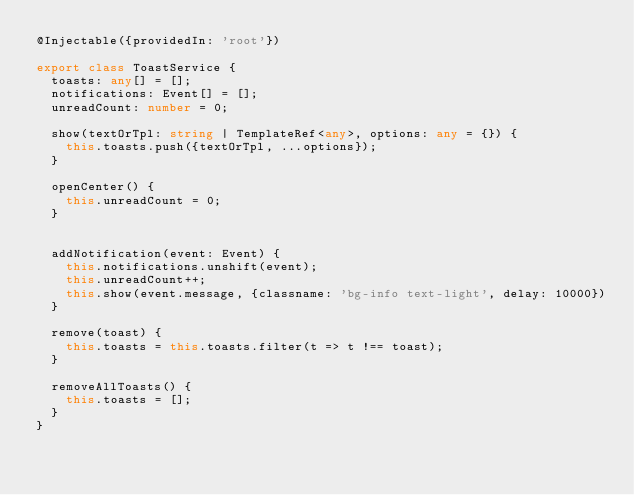Convert code to text. <code><loc_0><loc_0><loc_500><loc_500><_TypeScript_>@Injectable({providedIn: 'root'})

export class ToastService {
  toasts: any[] = [];
  notifications: Event[] = [];
  unreadCount: number = 0;

  show(textOrTpl: string | TemplateRef<any>, options: any = {}) {
    this.toasts.push({textOrTpl, ...options});
  }

  openCenter() {
    this.unreadCount = 0;
  }


  addNotification(event: Event) {
    this.notifications.unshift(event);
    this.unreadCount++;
    this.show(event.message, {classname: 'bg-info text-light', delay: 10000})
  }

  remove(toast) {
    this.toasts = this.toasts.filter(t => t !== toast);
  }

  removeAllToasts() {
    this.toasts = [];
  }
}
</code> 